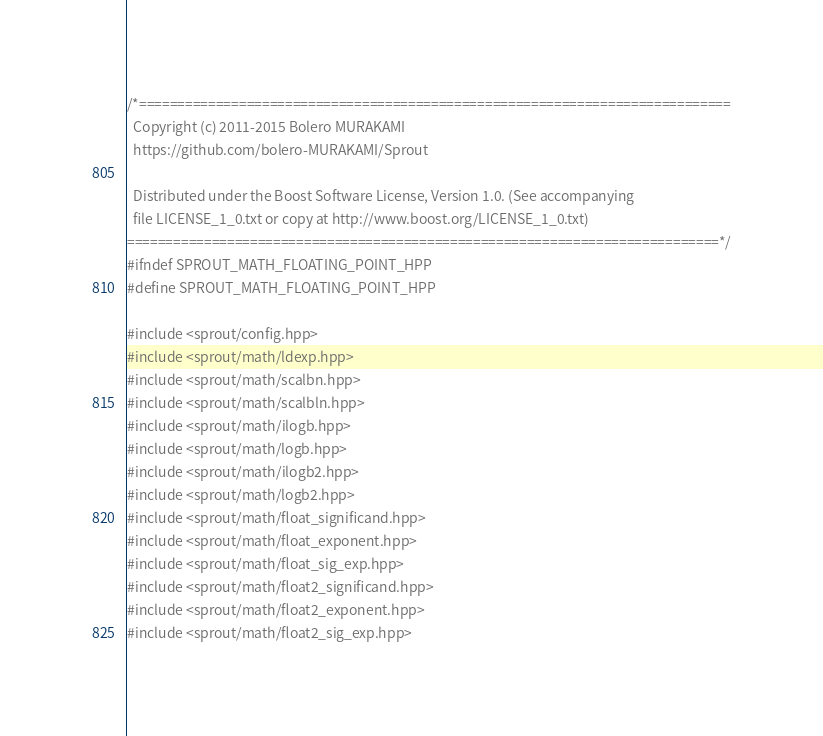Convert code to text. <code><loc_0><loc_0><loc_500><loc_500><_C++_>/*=============================================================================
  Copyright (c) 2011-2015 Bolero MURAKAMI
  https://github.com/bolero-MURAKAMI/Sprout

  Distributed under the Boost Software License, Version 1.0. (See accompanying
  file LICENSE_1_0.txt or copy at http://www.boost.org/LICENSE_1_0.txt)
=============================================================================*/
#ifndef SPROUT_MATH_FLOATING_POINT_HPP
#define SPROUT_MATH_FLOATING_POINT_HPP

#include <sprout/config.hpp>
#include <sprout/math/ldexp.hpp>
#include <sprout/math/scalbn.hpp>
#include <sprout/math/scalbln.hpp>
#include <sprout/math/ilogb.hpp>
#include <sprout/math/logb.hpp>
#include <sprout/math/ilogb2.hpp>
#include <sprout/math/logb2.hpp>
#include <sprout/math/float_significand.hpp>
#include <sprout/math/float_exponent.hpp>
#include <sprout/math/float_sig_exp.hpp>
#include <sprout/math/float2_significand.hpp>
#include <sprout/math/float2_exponent.hpp>
#include <sprout/math/float2_sig_exp.hpp></code> 